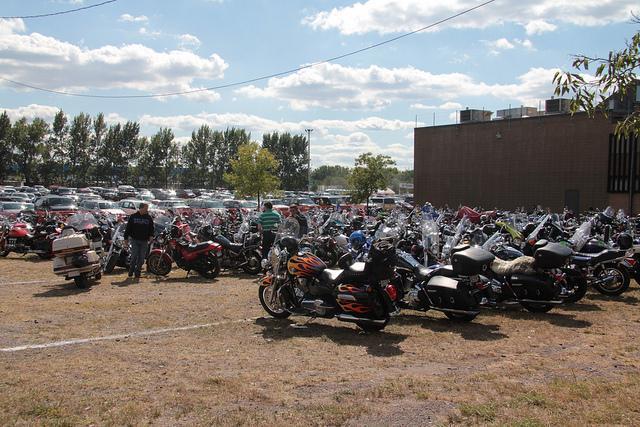The glare from the sun is distracting for drivers by reflecting off of what surface?
From the following four choices, select the correct answer to address the question.
Options: Pocket mirrors, cell phone, camera flash, motorcycle shields. Motorcycle shields. 